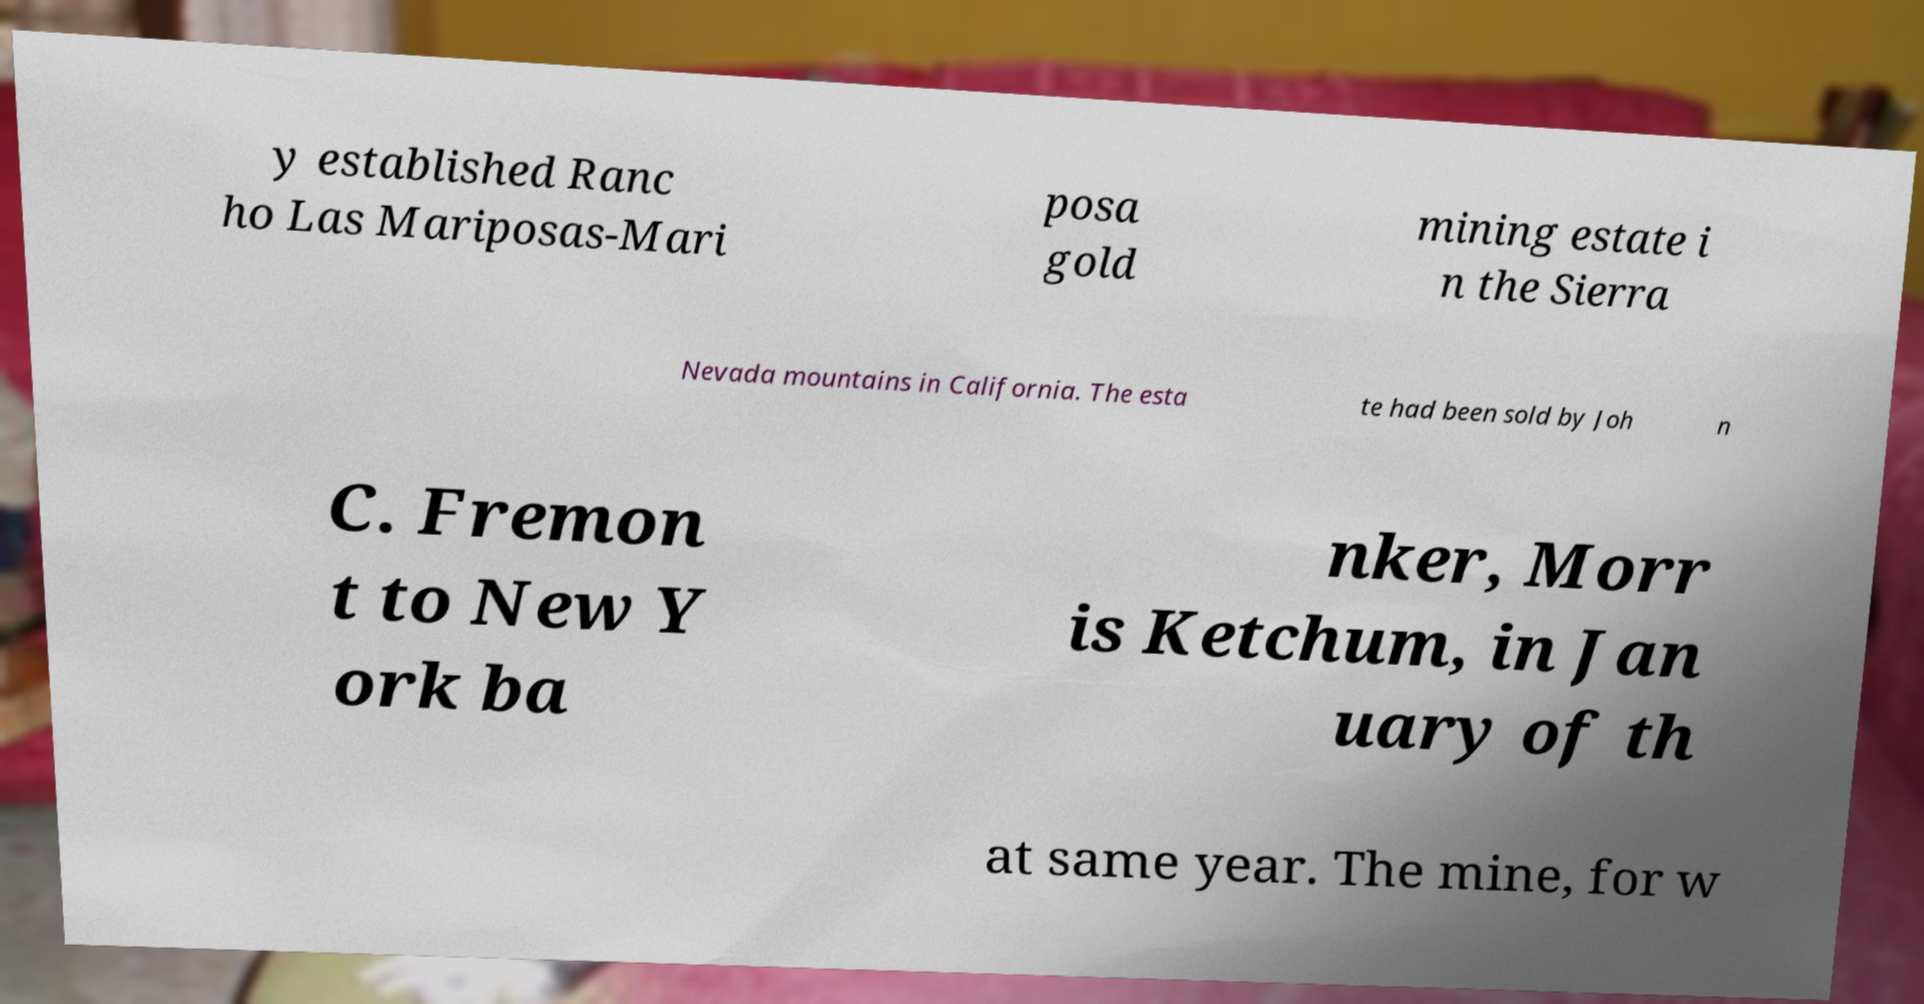Can you accurately transcribe the text from the provided image for me? y established Ranc ho Las Mariposas-Mari posa gold mining estate i n the Sierra Nevada mountains in California. The esta te had been sold by Joh n C. Fremon t to New Y ork ba nker, Morr is Ketchum, in Jan uary of th at same year. The mine, for w 